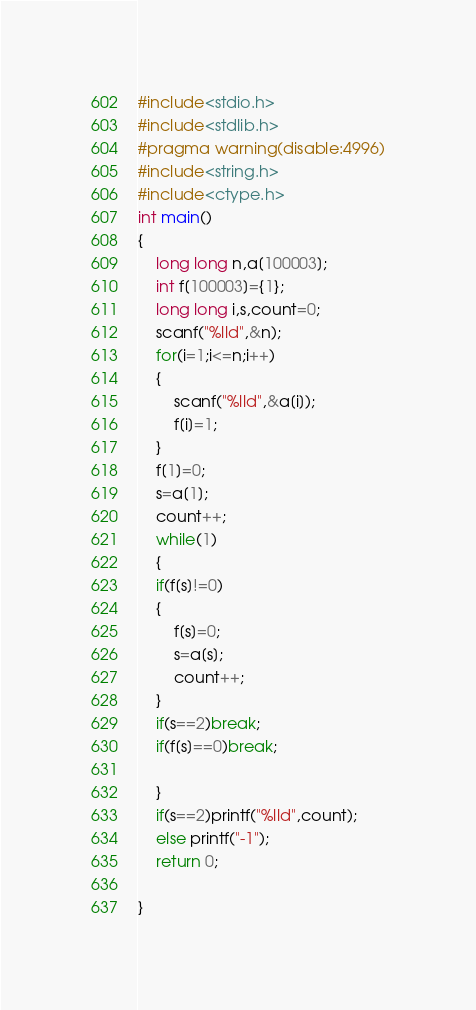<code> <loc_0><loc_0><loc_500><loc_500><_C_>#include<stdio.h>
#include<stdlib.h>
#pragma warning(disable:4996)
#include<string.h>
#include<ctype.h>
int main()
{
	long long n,a[100003];
	int f[100003]={1};
	long long i,s,count=0;
	scanf("%lld",&n);
	for(i=1;i<=n;i++)
	{
		scanf("%lld",&a[i]);
		f[i]=1;
	}
	f[1]=0;
	s=a[1];
	count++;
	while(1)
	{
	if(f[s]!=0)
	{
		f[s]=0;
		s=a[s];
		count++;
	}
	if(s==2)break;
	if(f[s]==0)break;
		
	}
	if(s==2)printf("%lld",count);
	else printf("-1");
	return 0;
	
}</code> 